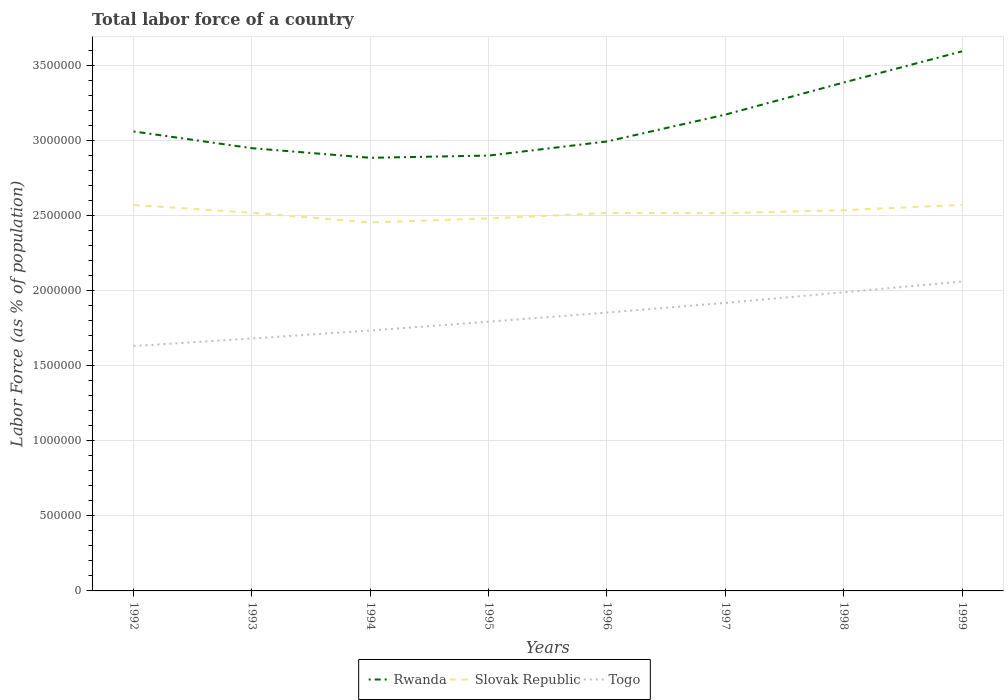How many different coloured lines are there?
Make the answer very short. 3. Does the line corresponding to Slovak Republic intersect with the line corresponding to Togo?
Give a very brief answer. No. Across all years, what is the maximum percentage of labor force in Togo?
Your answer should be very brief. 1.63e+06. What is the total percentage of labor force in Slovak Republic in the graph?
Provide a succinct answer. -5.50e+04. What is the difference between the highest and the second highest percentage of labor force in Togo?
Give a very brief answer. 4.30e+05. What is the difference between the highest and the lowest percentage of labor force in Rwanda?
Keep it short and to the point. 3. Are the values on the major ticks of Y-axis written in scientific E-notation?
Your answer should be compact. No. Does the graph contain grids?
Offer a very short reply. Yes. How many legend labels are there?
Your answer should be very brief. 3. What is the title of the graph?
Your response must be concise. Total labor force of a country. Does "Iraq" appear as one of the legend labels in the graph?
Provide a short and direct response. No. What is the label or title of the X-axis?
Your answer should be very brief. Years. What is the label or title of the Y-axis?
Ensure brevity in your answer.  Labor Force (as % of population). What is the Labor Force (as % of population) of Rwanda in 1992?
Give a very brief answer. 3.06e+06. What is the Labor Force (as % of population) of Slovak Republic in 1992?
Provide a succinct answer. 2.57e+06. What is the Labor Force (as % of population) of Togo in 1992?
Provide a short and direct response. 1.63e+06. What is the Labor Force (as % of population) of Rwanda in 1993?
Make the answer very short. 2.95e+06. What is the Labor Force (as % of population) in Slovak Republic in 1993?
Provide a succinct answer. 2.52e+06. What is the Labor Force (as % of population) in Togo in 1993?
Ensure brevity in your answer.  1.68e+06. What is the Labor Force (as % of population) of Rwanda in 1994?
Your answer should be very brief. 2.89e+06. What is the Labor Force (as % of population) of Slovak Republic in 1994?
Offer a very short reply. 2.45e+06. What is the Labor Force (as % of population) of Togo in 1994?
Provide a short and direct response. 1.73e+06. What is the Labor Force (as % of population) of Rwanda in 1995?
Your answer should be very brief. 2.90e+06. What is the Labor Force (as % of population) of Slovak Republic in 1995?
Your answer should be very brief. 2.48e+06. What is the Labor Force (as % of population) of Togo in 1995?
Provide a succinct answer. 1.79e+06. What is the Labor Force (as % of population) of Rwanda in 1996?
Offer a terse response. 2.99e+06. What is the Labor Force (as % of population) in Slovak Republic in 1996?
Give a very brief answer. 2.52e+06. What is the Labor Force (as % of population) of Togo in 1996?
Give a very brief answer. 1.85e+06. What is the Labor Force (as % of population) of Rwanda in 1997?
Your answer should be very brief. 3.17e+06. What is the Labor Force (as % of population) in Slovak Republic in 1997?
Make the answer very short. 2.52e+06. What is the Labor Force (as % of population) of Togo in 1997?
Ensure brevity in your answer.  1.92e+06. What is the Labor Force (as % of population) in Rwanda in 1998?
Your answer should be very brief. 3.39e+06. What is the Labor Force (as % of population) of Slovak Republic in 1998?
Keep it short and to the point. 2.54e+06. What is the Labor Force (as % of population) in Togo in 1998?
Provide a succinct answer. 1.99e+06. What is the Labor Force (as % of population) in Rwanda in 1999?
Give a very brief answer. 3.59e+06. What is the Labor Force (as % of population) in Slovak Republic in 1999?
Provide a short and direct response. 2.57e+06. What is the Labor Force (as % of population) in Togo in 1999?
Your answer should be very brief. 2.06e+06. Across all years, what is the maximum Labor Force (as % of population) of Rwanda?
Keep it short and to the point. 3.59e+06. Across all years, what is the maximum Labor Force (as % of population) in Slovak Republic?
Give a very brief answer. 2.57e+06. Across all years, what is the maximum Labor Force (as % of population) of Togo?
Your answer should be compact. 2.06e+06. Across all years, what is the minimum Labor Force (as % of population) in Rwanda?
Make the answer very short. 2.89e+06. Across all years, what is the minimum Labor Force (as % of population) in Slovak Republic?
Your answer should be compact. 2.45e+06. Across all years, what is the minimum Labor Force (as % of population) in Togo?
Ensure brevity in your answer.  1.63e+06. What is the total Labor Force (as % of population) in Rwanda in the graph?
Make the answer very short. 2.49e+07. What is the total Labor Force (as % of population) in Slovak Republic in the graph?
Your answer should be compact. 2.02e+07. What is the total Labor Force (as % of population) in Togo in the graph?
Ensure brevity in your answer.  1.47e+07. What is the difference between the Labor Force (as % of population) in Rwanda in 1992 and that in 1993?
Offer a very short reply. 1.12e+05. What is the difference between the Labor Force (as % of population) of Slovak Republic in 1992 and that in 1993?
Make the answer very short. 5.18e+04. What is the difference between the Labor Force (as % of population) of Togo in 1992 and that in 1993?
Ensure brevity in your answer.  -5.02e+04. What is the difference between the Labor Force (as % of population) of Rwanda in 1992 and that in 1994?
Give a very brief answer. 1.76e+05. What is the difference between the Labor Force (as % of population) of Slovak Republic in 1992 and that in 1994?
Your response must be concise. 1.16e+05. What is the difference between the Labor Force (as % of population) of Togo in 1992 and that in 1994?
Keep it short and to the point. -1.03e+05. What is the difference between the Labor Force (as % of population) in Rwanda in 1992 and that in 1995?
Keep it short and to the point. 1.61e+05. What is the difference between the Labor Force (as % of population) of Slovak Republic in 1992 and that in 1995?
Your answer should be very brief. 8.97e+04. What is the difference between the Labor Force (as % of population) in Togo in 1992 and that in 1995?
Your answer should be very brief. -1.62e+05. What is the difference between the Labor Force (as % of population) of Rwanda in 1992 and that in 1996?
Offer a terse response. 6.68e+04. What is the difference between the Labor Force (as % of population) of Slovak Republic in 1992 and that in 1996?
Provide a short and direct response. 5.32e+04. What is the difference between the Labor Force (as % of population) in Togo in 1992 and that in 1996?
Make the answer very short. -2.23e+05. What is the difference between the Labor Force (as % of population) of Rwanda in 1992 and that in 1997?
Give a very brief answer. -1.12e+05. What is the difference between the Labor Force (as % of population) of Slovak Republic in 1992 and that in 1997?
Your answer should be compact. 5.40e+04. What is the difference between the Labor Force (as % of population) in Togo in 1992 and that in 1997?
Ensure brevity in your answer.  -2.87e+05. What is the difference between the Labor Force (as % of population) in Rwanda in 1992 and that in 1998?
Give a very brief answer. -3.26e+05. What is the difference between the Labor Force (as % of population) in Slovak Republic in 1992 and that in 1998?
Your response must be concise. 3.47e+04. What is the difference between the Labor Force (as % of population) of Togo in 1992 and that in 1998?
Your answer should be very brief. -3.58e+05. What is the difference between the Labor Force (as % of population) in Rwanda in 1992 and that in 1999?
Offer a very short reply. -5.34e+05. What is the difference between the Labor Force (as % of population) in Slovak Republic in 1992 and that in 1999?
Make the answer very short. -1093. What is the difference between the Labor Force (as % of population) in Togo in 1992 and that in 1999?
Provide a succinct answer. -4.30e+05. What is the difference between the Labor Force (as % of population) of Rwanda in 1993 and that in 1994?
Offer a terse response. 6.39e+04. What is the difference between the Labor Force (as % of population) of Slovak Republic in 1993 and that in 1994?
Your answer should be compact. 6.44e+04. What is the difference between the Labor Force (as % of population) in Togo in 1993 and that in 1994?
Keep it short and to the point. -5.31e+04. What is the difference between the Labor Force (as % of population) of Rwanda in 1993 and that in 1995?
Keep it short and to the point. 4.92e+04. What is the difference between the Labor Force (as % of population) in Slovak Republic in 1993 and that in 1995?
Your answer should be very brief. 3.79e+04. What is the difference between the Labor Force (as % of population) of Togo in 1993 and that in 1995?
Give a very brief answer. -1.12e+05. What is the difference between the Labor Force (as % of population) of Rwanda in 1993 and that in 1996?
Your answer should be very brief. -4.48e+04. What is the difference between the Labor Force (as % of population) of Slovak Republic in 1993 and that in 1996?
Offer a terse response. 1414. What is the difference between the Labor Force (as % of population) of Togo in 1993 and that in 1996?
Your answer should be compact. -1.73e+05. What is the difference between the Labor Force (as % of population) in Rwanda in 1993 and that in 1997?
Make the answer very short. -2.24e+05. What is the difference between the Labor Force (as % of population) in Slovak Republic in 1993 and that in 1997?
Keep it short and to the point. 2242. What is the difference between the Labor Force (as % of population) in Togo in 1993 and that in 1997?
Give a very brief answer. -2.37e+05. What is the difference between the Labor Force (as % of population) of Rwanda in 1993 and that in 1998?
Provide a short and direct response. -4.38e+05. What is the difference between the Labor Force (as % of population) in Slovak Republic in 1993 and that in 1998?
Offer a very short reply. -1.71e+04. What is the difference between the Labor Force (as % of population) in Togo in 1993 and that in 1998?
Your answer should be compact. -3.08e+05. What is the difference between the Labor Force (as % of population) of Rwanda in 1993 and that in 1999?
Keep it short and to the point. -6.45e+05. What is the difference between the Labor Force (as % of population) of Slovak Republic in 1993 and that in 1999?
Ensure brevity in your answer.  -5.29e+04. What is the difference between the Labor Force (as % of population) in Togo in 1993 and that in 1999?
Offer a very short reply. -3.79e+05. What is the difference between the Labor Force (as % of population) in Rwanda in 1994 and that in 1995?
Ensure brevity in your answer.  -1.48e+04. What is the difference between the Labor Force (as % of population) of Slovak Republic in 1994 and that in 1995?
Keep it short and to the point. -2.65e+04. What is the difference between the Labor Force (as % of population) in Togo in 1994 and that in 1995?
Your answer should be compact. -5.88e+04. What is the difference between the Labor Force (as % of population) of Rwanda in 1994 and that in 1996?
Your answer should be compact. -1.09e+05. What is the difference between the Labor Force (as % of population) in Slovak Republic in 1994 and that in 1996?
Your answer should be compact. -6.30e+04. What is the difference between the Labor Force (as % of population) of Togo in 1994 and that in 1996?
Provide a short and direct response. -1.20e+05. What is the difference between the Labor Force (as % of population) of Rwanda in 1994 and that in 1997?
Offer a terse response. -2.88e+05. What is the difference between the Labor Force (as % of population) of Slovak Republic in 1994 and that in 1997?
Your answer should be compact. -6.22e+04. What is the difference between the Labor Force (as % of population) of Togo in 1994 and that in 1997?
Give a very brief answer. -1.84e+05. What is the difference between the Labor Force (as % of population) of Rwanda in 1994 and that in 1998?
Offer a terse response. -5.01e+05. What is the difference between the Labor Force (as % of population) in Slovak Republic in 1994 and that in 1998?
Offer a terse response. -8.16e+04. What is the difference between the Labor Force (as % of population) in Togo in 1994 and that in 1998?
Your response must be concise. -2.55e+05. What is the difference between the Labor Force (as % of population) in Rwanda in 1994 and that in 1999?
Keep it short and to the point. -7.09e+05. What is the difference between the Labor Force (as % of population) of Slovak Republic in 1994 and that in 1999?
Your answer should be compact. -1.17e+05. What is the difference between the Labor Force (as % of population) of Togo in 1994 and that in 1999?
Give a very brief answer. -3.26e+05. What is the difference between the Labor Force (as % of population) in Rwanda in 1995 and that in 1996?
Provide a short and direct response. -9.40e+04. What is the difference between the Labor Force (as % of population) in Slovak Republic in 1995 and that in 1996?
Provide a short and direct response. -3.65e+04. What is the difference between the Labor Force (as % of population) in Togo in 1995 and that in 1996?
Your answer should be compact. -6.08e+04. What is the difference between the Labor Force (as % of population) in Rwanda in 1995 and that in 1997?
Offer a terse response. -2.73e+05. What is the difference between the Labor Force (as % of population) in Slovak Republic in 1995 and that in 1997?
Your answer should be compact. -3.57e+04. What is the difference between the Labor Force (as % of population) of Togo in 1995 and that in 1997?
Ensure brevity in your answer.  -1.25e+05. What is the difference between the Labor Force (as % of population) in Rwanda in 1995 and that in 1998?
Ensure brevity in your answer.  -4.87e+05. What is the difference between the Labor Force (as % of population) in Slovak Republic in 1995 and that in 1998?
Your answer should be very brief. -5.50e+04. What is the difference between the Labor Force (as % of population) of Togo in 1995 and that in 1998?
Give a very brief answer. -1.96e+05. What is the difference between the Labor Force (as % of population) of Rwanda in 1995 and that in 1999?
Offer a terse response. -6.94e+05. What is the difference between the Labor Force (as % of population) in Slovak Republic in 1995 and that in 1999?
Provide a succinct answer. -9.08e+04. What is the difference between the Labor Force (as % of population) in Togo in 1995 and that in 1999?
Keep it short and to the point. -2.68e+05. What is the difference between the Labor Force (as % of population) of Rwanda in 1996 and that in 1997?
Offer a terse response. -1.79e+05. What is the difference between the Labor Force (as % of population) of Slovak Republic in 1996 and that in 1997?
Your answer should be compact. 828. What is the difference between the Labor Force (as % of population) of Togo in 1996 and that in 1997?
Provide a succinct answer. -6.45e+04. What is the difference between the Labor Force (as % of population) of Rwanda in 1996 and that in 1998?
Keep it short and to the point. -3.93e+05. What is the difference between the Labor Force (as % of population) in Slovak Republic in 1996 and that in 1998?
Offer a terse response. -1.85e+04. What is the difference between the Labor Force (as % of population) of Togo in 1996 and that in 1998?
Provide a succinct answer. -1.35e+05. What is the difference between the Labor Force (as % of population) of Rwanda in 1996 and that in 1999?
Provide a succinct answer. -6.00e+05. What is the difference between the Labor Force (as % of population) in Slovak Republic in 1996 and that in 1999?
Give a very brief answer. -5.43e+04. What is the difference between the Labor Force (as % of population) of Togo in 1996 and that in 1999?
Provide a short and direct response. -2.07e+05. What is the difference between the Labor Force (as % of population) of Rwanda in 1997 and that in 1998?
Keep it short and to the point. -2.14e+05. What is the difference between the Labor Force (as % of population) in Slovak Republic in 1997 and that in 1998?
Make the answer very short. -1.93e+04. What is the difference between the Labor Force (as % of population) in Togo in 1997 and that in 1998?
Make the answer very short. -7.06e+04. What is the difference between the Labor Force (as % of population) of Rwanda in 1997 and that in 1999?
Provide a short and direct response. -4.22e+05. What is the difference between the Labor Force (as % of population) in Slovak Republic in 1997 and that in 1999?
Offer a very short reply. -5.51e+04. What is the difference between the Labor Force (as % of population) of Togo in 1997 and that in 1999?
Provide a succinct answer. -1.42e+05. What is the difference between the Labor Force (as % of population) of Rwanda in 1998 and that in 1999?
Keep it short and to the point. -2.08e+05. What is the difference between the Labor Force (as % of population) of Slovak Republic in 1998 and that in 1999?
Your answer should be very brief. -3.58e+04. What is the difference between the Labor Force (as % of population) of Togo in 1998 and that in 1999?
Offer a very short reply. -7.16e+04. What is the difference between the Labor Force (as % of population) in Rwanda in 1992 and the Labor Force (as % of population) in Slovak Republic in 1993?
Provide a short and direct response. 5.42e+05. What is the difference between the Labor Force (as % of population) in Rwanda in 1992 and the Labor Force (as % of population) in Togo in 1993?
Ensure brevity in your answer.  1.38e+06. What is the difference between the Labor Force (as % of population) of Slovak Republic in 1992 and the Labor Force (as % of population) of Togo in 1993?
Your response must be concise. 8.89e+05. What is the difference between the Labor Force (as % of population) of Rwanda in 1992 and the Labor Force (as % of population) of Slovak Republic in 1994?
Your answer should be compact. 6.06e+05. What is the difference between the Labor Force (as % of population) of Rwanda in 1992 and the Labor Force (as % of population) of Togo in 1994?
Keep it short and to the point. 1.33e+06. What is the difference between the Labor Force (as % of population) in Slovak Republic in 1992 and the Labor Force (as % of population) in Togo in 1994?
Your answer should be very brief. 8.36e+05. What is the difference between the Labor Force (as % of population) in Rwanda in 1992 and the Labor Force (as % of population) in Slovak Republic in 1995?
Ensure brevity in your answer.  5.80e+05. What is the difference between the Labor Force (as % of population) of Rwanda in 1992 and the Labor Force (as % of population) of Togo in 1995?
Offer a terse response. 1.27e+06. What is the difference between the Labor Force (as % of population) of Slovak Republic in 1992 and the Labor Force (as % of population) of Togo in 1995?
Your answer should be very brief. 7.77e+05. What is the difference between the Labor Force (as % of population) in Rwanda in 1992 and the Labor Force (as % of population) in Slovak Republic in 1996?
Offer a very short reply. 5.43e+05. What is the difference between the Labor Force (as % of population) of Rwanda in 1992 and the Labor Force (as % of population) of Togo in 1996?
Give a very brief answer. 1.21e+06. What is the difference between the Labor Force (as % of population) in Slovak Republic in 1992 and the Labor Force (as % of population) in Togo in 1996?
Offer a very short reply. 7.17e+05. What is the difference between the Labor Force (as % of population) of Rwanda in 1992 and the Labor Force (as % of population) of Slovak Republic in 1997?
Your answer should be very brief. 5.44e+05. What is the difference between the Labor Force (as % of population) of Rwanda in 1992 and the Labor Force (as % of population) of Togo in 1997?
Ensure brevity in your answer.  1.14e+06. What is the difference between the Labor Force (as % of population) of Slovak Republic in 1992 and the Labor Force (as % of population) of Togo in 1997?
Provide a short and direct response. 6.52e+05. What is the difference between the Labor Force (as % of population) in Rwanda in 1992 and the Labor Force (as % of population) in Slovak Republic in 1998?
Your answer should be compact. 5.25e+05. What is the difference between the Labor Force (as % of population) of Rwanda in 1992 and the Labor Force (as % of population) of Togo in 1998?
Provide a succinct answer. 1.07e+06. What is the difference between the Labor Force (as % of population) in Slovak Republic in 1992 and the Labor Force (as % of population) in Togo in 1998?
Make the answer very short. 5.82e+05. What is the difference between the Labor Force (as % of population) of Rwanda in 1992 and the Labor Force (as % of population) of Slovak Republic in 1999?
Give a very brief answer. 4.89e+05. What is the difference between the Labor Force (as % of population) in Rwanda in 1992 and the Labor Force (as % of population) in Togo in 1999?
Provide a succinct answer. 1.00e+06. What is the difference between the Labor Force (as % of population) in Slovak Republic in 1992 and the Labor Force (as % of population) in Togo in 1999?
Provide a short and direct response. 5.10e+05. What is the difference between the Labor Force (as % of population) of Rwanda in 1993 and the Labor Force (as % of population) of Slovak Republic in 1994?
Offer a terse response. 4.95e+05. What is the difference between the Labor Force (as % of population) in Rwanda in 1993 and the Labor Force (as % of population) in Togo in 1994?
Make the answer very short. 1.21e+06. What is the difference between the Labor Force (as % of population) in Slovak Republic in 1993 and the Labor Force (as % of population) in Togo in 1994?
Your answer should be compact. 7.84e+05. What is the difference between the Labor Force (as % of population) in Rwanda in 1993 and the Labor Force (as % of population) in Slovak Republic in 1995?
Offer a terse response. 4.68e+05. What is the difference between the Labor Force (as % of population) in Rwanda in 1993 and the Labor Force (as % of population) in Togo in 1995?
Provide a succinct answer. 1.16e+06. What is the difference between the Labor Force (as % of population) of Slovak Republic in 1993 and the Labor Force (as % of population) of Togo in 1995?
Your answer should be very brief. 7.26e+05. What is the difference between the Labor Force (as % of population) of Rwanda in 1993 and the Labor Force (as % of population) of Slovak Republic in 1996?
Provide a succinct answer. 4.32e+05. What is the difference between the Labor Force (as % of population) in Rwanda in 1993 and the Labor Force (as % of population) in Togo in 1996?
Make the answer very short. 1.09e+06. What is the difference between the Labor Force (as % of population) in Slovak Republic in 1993 and the Labor Force (as % of population) in Togo in 1996?
Keep it short and to the point. 6.65e+05. What is the difference between the Labor Force (as % of population) of Rwanda in 1993 and the Labor Force (as % of population) of Slovak Republic in 1997?
Ensure brevity in your answer.  4.32e+05. What is the difference between the Labor Force (as % of population) of Rwanda in 1993 and the Labor Force (as % of population) of Togo in 1997?
Provide a short and direct response. 1.03e+06. What is the difference between the Labor Force (as % of population) in Slovak Republic in 1993 and the Labor Force (as % of population) in Togo in 1997?
Keep it short and to the point. 6.00e+05. What is the difference between the Labor Force (as % of population) of Rwanda in 1993 and the Labor Force (as % of population) of Slovak Republic in 1998?
Your answer should be very brief. 4.13e+05. What is the difference between the Labor Force (as % of population) of Rwanda in 1993 and the Labor Force (as % of population) of Togo in 1998?
Give a very brief answer. 9.60e+05. What is the difference between the Labor Force (as % of population) of Slovak Republic in 1993 and the Labor Force (as % of population) of Togo in 1998?
Offer a terse response. 5.30e+05. What is the difference between the Labor Force (as % of population) of Rwanda in 1993 and the Labor Force (as % of population) of Slovak Republic in 1999?
Provide a short and direct response. 3.77e+05. What is the difference between the Labor Force (as % of population) in Rwanda in 1993 and the Labor Force (as % of population) in Togo in 1999?
Give a very brief answer. 8.88e+05. What is the difference between the Labor Force (as % of population) of Slovak Republic in 1993 and the Labor Force (as % of population) of Togo in 1999?
Your answer should be very brief. 4.58e+05. What is the difference between the Labor Force (as % of population) of Rwanda in 1994 and the Labor Force (as % of population) of Slovak Republic in 1995?
Make the answer very short. 4.04e+05. What is the difference between the Labor Force (as % of population) of Rwanda in 1994 and the Labor Force (as % of population) of Togo in 1995?
Give a very brief answer. 1.09e+06. What is the difference between the Labor Force (as % of population) of Slovak Republic in 1994 and the Labor Force (as % of population) of Togo in 1995?
Ensure brevity in your answer.  6.61e+05. What is the difference between the Labor Force (as % of population) of Rwanda in 1994 and the Labor Force (as % of population) of Slovak Republic in 1996?
Your response must be concise. 3.68e+05. What is the difference between the Labor Force (as % of population) in Rwanda in 1994 and the Labor Force (as % of population) in Togo in 1996?
Your response must be concise. 1.03e+06. What is the difference between the Labor Force (as % of population) of Slovak Republic in 1994 and the Labor Force (as % of population) of Togo in 1996?
Provide a short and direct response. 6.00e+05. What is the difference between the Labor Force (as % of population) of Rwanda in 1994 and the Labor Force (as % of population) of Slovak Republic in 1997?
Your answer should be compact. 3.68e+05. What is the difference between the Labor Force (as % of population) of Rwanda in 1994 and the Labor Force (as % of population) of Togo in 1997?
Offer a terse response. 9.67e+05. What is the difference between the Labor Force (as % of population) in Slovak Republic in 1994 and the Labor Force (as % of population) in Togo in 1997?
Provide a succinct answer. 5.36e+05. What is the difference between the Labor Force (as % of population) in Rwanda in 1994 and the Labor Force (as % of population) in Slovak Republic in 1998?
Ensure brevity in your answer.  3.49e+05. What is the difference between the Labor Force (as % of population) of Rwanda in 1994 and the Labor Force (as % of population) of Togo in 1998?
Keep it short and to the point. 8.96e+05. What is the difference between the Labor Force (as % of population) of Slovak Republic in 1994 and the Labor Force (as % of population) of Togo in 1998?
Give a very brief answer. 4.65e+05. What is the difference between the Labor Force (as % of population) in Rwanda in 1994 and the Labor Force (as % of population) in Slovak Republic in 1999?
Your answer should be very brief. 3.13e+05. What is the difference between the Labor Force (as % of population) in Rwanda in 1994 and the Labor Force (as % of population) in Togo in 1999?
Offer a very short reply. 8.24e+05. What is the difference between the Labor Force (as % of population) in Slovak Republic in 1994 and the Labor Force (as % of population) in Togo in 1999?
Offer a terse response. 3.94e+05. What is the difference between the Labor Force (as % of population) in Rwanda in 1995 and the Labor Force (as % of population) in Slovak Republic in 1996?
Ensure brevity in your answer.  3.82e+05. What is the difference between the Labor Force (as % of population) of Rwanda in 1995 and the Labor Force (as % of population) of Togo in 1996?
Provide a short and direct response. 1.05e+06. What is the difference between the Labor Force (as % of population) of Slovak Republic in 1995 and the Labor Force (as % of population) of Togo in 1996?
Give a very brief answer. 6.27e+05. What is the difference between the Labor Force (as % of population) of Rwanda in 1995 and the Labor Force (as % of population) of Slovak Republic in 1997?
Offer a very short reply. 3.83e+05. What is the difference between the Labor Force (as % of population) of Rwanda in 1995 and the Labor Force (as % of population) of Togo in 1997?
Provide a short and direct response. 9.81e+05. What is the difference between the Labor Force (as % of population) in Slovak Republic in 1995 and the Labor Force (as % of population) in Togo in 1997?
Provide a short and direct response. 5.62e+05. What is the difference between the Labor Force (as % of population) in Rwanda in 1995 and the Labor Force (as % of population) in Slovak Republic in 1998?
Keep it short and to the point. 3.64e+05. What is the difference between the Labor Force (as % of population) in Rwanda in 1995 and the Labor Force (as % of population) in Togo in 1998?
Ensure brevity in your answer.  9.11e+05. What is the difference between the Labor Force (as % of population) in Slovak Republic in 1995 and the Labor Force (as % of population) in Togo in 1998?
Ensure brevity in your answer.  4.92e+05. What is the difference between the Labor Force (as % of population) of Rwanda in 1995 and the Labor Force (as % of population) of Slovak Republic in 1999?
Offer a very short reply. 3.28e+05. What is the difference between the Labor Force (as % of population) in Rwanda in 1995 and the Labor Force (as % of population) in Togo in 1999?
Your response must be concise. 8.39e+05. What is the difference between the Labor Force (as % of population) in Slovak Republic in 1995 and the Labor Force (as % of population) in Togo in 1999?
Offer a terse response. 4.20e+05. What is the difference between the Labor Force (as % of population) in Rwanda in 1996 and the Labor Force (as % of population) in Slovak Republic in 1997?
Ensure brevity in your answer.  4.77e+05. What is the difference between the Labor Force (as % of population) in Rwanda in 1996 and the Labor Force (as % of population) in Togo in 1997?
Your response must be concise. 1.08e+06. What is the difference between the Labor Force (as % of population) of Slovak Republic in 1996 and the Labor Force (as % of population) of Togo in 1997?
Your answer should be very brief. 5.99e+05. What is the difference between the Labor Force (as % of population) in Rwanda in 1996 and the Labor Force (as % of population) in Slovak Republic in 1998?
Provide a short and direct response. 4.58e+05. What is the difference between the Labor Force (as % of population) in Rwanda in 1996 and the Labor Force (as % of population) in Togo in 1998?
Ensure brevity in your answer.  1.00e+06. What is the difference between the Labor Force (as % of population) in Slovak Republic in 1996 and the Labor Force (as % of population) in Togo in 1998?
Give a very brief answer. 5.28e+05. What is the difference between the Labor Force (as % of population) of Rwanda in 1996 and the Labor Force (as % of population) of Slovak Republic in 1999?
Provide a succinct answer. 4.22e+05. What is the difference between the Labor Force (as % of population) in Rwanda in 1996 and the Labor Force (as % of population) in Togo in 1999?
Make the answer very short. 9.33e+05. What is the difference between the Labor Force (as % of population) in Slovak Republic in 1996 and the Labor Force (as % of population) in Togo in 1999?
Offer a terse response. 4.57e+05. What is the difference between the Labor Force (as % of population) of Rwanda in 1997 and the Labor Force (as % of population) of Slovak Republic in 1998?
Offer a terse response. 6.37e+05. What is the difference between the Labor Force (as % of population) of Rwanda in 1997 and the Labor Force (as % of population) of Togo in 1998?
Give a very brief answer. 1.18e+06. What is the difference between the Labor Force (as % of population) of Slovak Republic in 1997 and the Labor Force (as % of population) of Togo in 1998?
Provide a short and direct response. 5.27e+05. What is the difference between the Labor Force (as % of population) in Rwanda in 1997 and the Labor Force (as % of population) in Slovak Republic in 1999?
Provide a short and direct response. 6.01e+05. What is the difference between the Labor Force (as % of population) in Rwanda in 1997 and the Labor Force (as % of population) in Togo in 1999?
Provide a short and direct response. 1.11e+06. What is the difference between the Labor Force (as % of population) in Slovak Republic in 1997 and the Labor Force (as % of population) in Togo in 1999?
Ensure brevity in your answer.  4.56e+05. What is the difference between the Labor Force (as % of population) in Rwanda in 1998 and the Labor Force (as % of population) in Slovak Republic in 1999?
Provide a short and direct response. 8.15e+05. What is the difference between the Labor Force (as % of population) of Rwanda in 1998 and the Labor Force (as % of population) of Togo in 1999?
Give a very brief answer. 1.33e+06. What is the difference between the Labor Force (as % of population) of Slovak Republic in 1998 and the Labor Force (as % of population) of Togo in 1999?
Offer a terse response. 4.75e+05. What is the average Labor Force (as % of population) of Rwanda per year?
Offer a very short reply. 3.12e+06. What is the average Labor Force (as % of population) in Slovak Republic per year?
Your answer should be very brief. 2.52e+06. What is the average Labor Force (as % of population) in Togo per year?
Your response must be concise. 1.83e+06. In the year 1992, what is the difference between the Labor Force (as % of population) in Rwanda and Labor Force (as % of population) in Slovak Republic?
Keep it short and to the point. 4.90e+05. In the year 1992, what is the difference between the Labor Force (as % of population) of Rwanda and Labor Force (as % of population) of Togo?
Your answer should be very brief. 1.43e+06. In the year 1992, what is the difference between the Labor Force (as % of population) of Slovak Republic and Labor Force (as % of population) of Togo?
Ensure brevity in your answer.  9.39e+05. In the year 1993, what is the difference between the Labor Force (as % of population) in Rwanda and Labor Force (as % of population) in Slovak Republic?
Your answer should be compact. 4.30e+05. In the year 1993, what is the difference between the Labor Force (as % of population) in Rwanda and Labor Force (as % of population) in Togo?
Your answer should be compact. 1.27e+06. In the year 1993, what is the difference between the Labor Force (as % of population) of Slovak Republic and Labor Force (as % of population) of Togo?
Offer a terse response. 8.38e+05. In the year 1994, what is the difference between the Labor Force (as % of population) in Rwanda and Labor Force (as % of population) in Slovak Republic?
Give a very brief answer. 4.31e+05. In the year 1994, what is the difference between the Labor Force (as % of population) of Rwanda and Labor Force (as % of population) of Togo?
Provide a succinct answer. 1.15e+06. In the year 1994, what is the difference between the Labor Force (as % of population) of Slovak Republic and Labor Force (as % of population) of Togo?
Offer a very short reply. 7.20e+05. In the year 1995, what is the difference between the Labor Force (as % of population) in Rwanda and Labor Force (as % of population) in Slovak Republic?
Make the answer very short. 4.19e+05. In the year 1995, what is the difference between the Labor Force (as % of population) of Rwanda and Labor Force (as % of population) of Togo?
Give a very brief answer. 1.11e+06. In the year 1995, what is the difference between the Labor Force (as % of population) of Slovak Republic and Labor Force (as % of population) of Togo?
Your response must be concise. 6.88e+05. In the year 1996, what is the difference between the Labor Force (as % of population) in Rwanda and Labor Force (as % of population) in Slovak Republic?
Provide a short and direct response. 4.76e+05. In the year 1996, what is the difference between the Labor Force (as % of population) of Rwanda and Labor Force (as % of population) of Togo?
Provide a succinct answer. 1.14e+06. In the year 1996, what is the difference between the Labor Force (as % of population) in Slovak Republic and Labor Force (as % of population) in Togo?
Keep it short and to the point. 6.63e+05. In the year 1997, what is the difference between the Labor Force (as % of population) of Rwanda and Labor Force (as % of population) of Slovak Republic?
Give a very brief answer. 6.56e+05. In the year 1997, what is the difference between the Labor Force (as % of population) of Rwanda and Labor Force (as % of population) of Togo?
Ensure brevity in your answer.  1.25e+06. In the year 1997, what is the difference between the Labor Force (as % of population) in Slovak Republic and Labor Force (as % of population) in Togo?
Provide a succinct answer. 5.98e+05. In the year 1998, what is the difference between the Labor Force (as % of population) of Rwanda and Labor Force (as % of population) of Slovak Republic?
Provide a short and direct response. 8.51e+05. In the year 1998, what is the difference between the Labor Force (as % of population) of Rwanda and Labor Force (as % of population) of Togo?
Your response must be concise. 1.40e+06. In the year 1998, what is the difference between the Labor Force (as % of population) of Slovak Republic and Labor Force (as % of population) of Togo?
Offer a terse response. 5.47e+05. In the year 1999, what is the difference between the Labor Force (as % of population) in Rwanda and Labor Force (as % of population) in Slovak Republic?
Ensure brevity in your answer.  1.02e+06. In the year 1999, what is the difference between the Labor Force (as % of population) of Rwanda and Labor Force (as % of population) of Togo?
Keep it short and to the point. 1.53e+06. In the year 1999, what is the difference between the Labor Force (as % of population) in Slovak Republic and Labor Force (as % of population) in Togo?
Provide a short and direct response. 5.11e+05. What is the ratio of the Labor Force (as % of population) in Rwanda in 1992 to that in 1993?
Make the answer very short. 1.04. What is the ratio of the Labor Force (as % of population) in Slovak Republic in 1992 to that in 1993?
Provide a succinct answer. 1.02. What is the ratio of the Labor Force (as % of population) in Togo in 1992 to that in 1993?
Your answer should be compact. 0.97. What is the ratio of the Labor Force (as % of population) in Rwanda in 1992 to that in 1994?
Make the answer very short. 1.06. What is the ratio of the Labor Force (as % of population) in Slovak Republic in 1992 to that in 1994?
Your response must be concise. 1.05. What is the ratio of the Labor Force (as % of population) in Togo in 1992 to that in 1994?
Your response must be concise. 0.94. What is the ratio of the Labor Force (as % of population) in Rwanda in 1992 to that in 1995?
Your answer should be compact. 1.06. What is the ratio of the Labor Force (as % of population) of Slovak Republic in 1992 to that in 1995?
Provide a short and direct response. 1.04. What is the ratio of the Labor Force (as % of population) of Togo in 1992 to that in 1995?
Your response must be concise. 0.91. What is the ratio of the Labor Force (as % of population) in Rwanda in 1992 to that in 1996?
Make the answer very short. 1.02. What is the ratio of the Labor Force (as % of population) of Slovak Republic in 1992 to that in 1996?
Offer a very short reply. 1.02. What is the ratio of the Labor Force (as % of population) of Togo in 1992 to that in 1996?
Give a very brief answer. 0.88. What is the ratio of the Labor Force (as % of population) of Rwanda in 1992 to that in 1997?
Your answer should be very brief. 0.96. What is the ratio of the Labor Force (as % of population) of Slovak Republic in 1992 to that in 1997?
Your answer should be very brief. 1.02. What is the ratio of the Labor Force (as % of population) of Togo in 1992 to that in 1997?
Provide a short and direct response. 0.85. What is the ratio of the Labor Force (as % of population) in Rwanda in 1992 to that in 1998?
Provide a short and direct response. 0.9. What is the ratio of the Labor Force (as % of population) of Slovak Republic in 1992 to that in 1998?
Provide a short and direct response. 1.01. What is the ratio of the Labor Force (as % of population) of Togo in 1992 to that in 1998?
Offer a very short reply. 0.82. What is the ratio of the Labor Force (as % of population) of Rwanda in 1992 to that in 1999?
Ensure brevity in your answer.  0.85. What is the ratio of the Labor Force (as % of population) in Slovak Republic in 1992 to that in 1999?
Make the answer very short. 1. What is the ratio of the Labor Force (as % of population) in Togo in 1992 to that in 1999?
Your answer should be very brief. 0.79. What is the ratio of the Labor Force (as % of population) of Rwanda in 1993 to that in 1994?
Your answer should be very brief. 1.02. What is the ratio of the Labor Force (as % of population) in Slovak Republic in 1993 to that in 1994?
Make the answer very short. 1.03. What is the ratio of the Labor Force (as % of population) in Togo in 1993 to that in 1994?
Give a very brief answer. 0.97. What is the ratio of the Labor Force (as % of population) in Rwanda in 1993 to that in 1995?
Keep it short and to the point. 1.02. What is the ratio of the Labor Force (as % of population) of Slovak Republic in 1993 to that in 1995?
Provide a succinct answer. 1.02. What is the ratio of the Labor Force (as % of population) in Togo in 1993 to that in 1995?
Provide a succinct answer. 0.94. What is the ratio of the Labor Force (as % of population) of Rwanda in 1993 to that in 1996?
Offer a very short reply. 0.98. What is the ratio of the Labor Force (as % of population) in Slovak Republic in 1993 to that in 1996?
Make the answer very short. 1. What is the ratio of the Labor Force (as % of population) in Togo in 1993 to that in 1996?
Offer a terse response. 0.91. What is the ratio of the Labor Force (as % of population) in Rwanda in 1993 to that in 1997?
Give a very brief answer. 0.93. What is the ratio of the Labor Force (as % of population) in Togo in 1993 to that in 1997?
Your answer should be very brief. 0.88. What is the ratio of the Labor Force (as % of population) in Rwanda in 1993 to that in 1998?
Give a very brief answer. 0.87. What is the ratio of the Labor Force (as % of population) of Togo in 1993 to that in 1998?
Make the answer very short. 0.85. What is the ratio of the Labor Force (as % of population) in Rwanda in 1993 to that in 1999?
Your answer should be compact. 0.82. What is the ratio of the Labor Force (as % of population) in Slovak Republic in 1993 to that in 1999?
Give a very brief answer. 0.98. What is the ratio of the Labor Force (as % of population) of Togo in 1993 to that in 1999?
Your answer should be very brief. 0.82. What is the ratio of the Labor Force (as % of population) in Rwanda in 1994 to that in 1995?
Offer a terse response. 0.99. What is the ratio of the Labor Force (as % of population) of Slovak Republic in 1994 to that in 1995?
Ensure brevity in your answer.  0.99. What is the ratio of the Labor Force (as % of population) in Togo in 1994 to that in 1995?
Your response must be concise. 0.97. What is the ratio of the Labor Force (as % of population) in Rwanda in 1994 to that in 1996?
Keep it short and to the point. 0.96. What is the ratio of the Labor Force (as % of population) of Slovak Republic in 1994 to that in 1996?
Give a very brief answer. 0.97. What is the ratio of the Labor Force (as % of population) in Togo in 1994 to that in 1996?
Your response must be concise. 0.94. What is the ratio of the Labor Force (as % of population) of Rwanda in 1994 to that in 1997?
Your answer should be very brief. 0.91. What is the ratio of the Labor Force (as % of population) in Slovak Republic in 1994 to that in 1997?
Offer a very short reply. 0.98. What is the ratio of the Labor Force (as % of population) of Togo in 1994 to that in 1997?
Your answer should be very brief. 0.9. What is the ratio of the Labor Force (as % of population) in Rwanda in 1994 to that in 1998?
Ensure brevity in your answer.  0.85. What is the ratio of the Labor Force (as % of population) in Slovak Republic in 1994 to that in 1998?
Give a very brief answer. 0.97. What is the ratio of the Labor Force (as % of population) of Togo in 1994 to that in 1998?
Your answer should be very brief. 0.87. What is the ratio of the Labor Force (as % of population) of Rwanda in 1994 to that in 1999?
Your response must be concise. 0.8. What is the ratio of the Labor Force (as % of population) in Slovak Republic in 1994 to that in 1999?
Provide a succinct answer. 0.95. What is the ratio of the Labor Force (as % of population) of Togo in 1994 to that in 1999?
Keep it short and to the point. 0.84. What is the ratio of the Labor Force (as % of population) of Rwanda in 1995 to that in 1996?
Offer a terse response. 0.97. What is the ratio of the Labor Force (as % of population) of Slovak Republic in 1995 to that in 1996?
Provide a short and direct response. 0.99. What is the ratio of the Labor Force (as % of population) in Togo in 1995 to that in 1996?
Provide a succinct answer. 0.97. What is the ratio of the Labor Force (as % of population) of Rwanda in 1995 to that in 1997?
Your answer should be very brief. 0.91. What is the ratio of the Labor Force (as % of population) of Slovak Republic in 1995 to that in 1997?
Make the answer very short. 0.99. What is the ratio of the Labor Force (as % of population) of Togo in 1995 to that in 1997?
Ensure brevity in your answer.  0.93. What is the ratio of the Labor Force (as % of population) in Rwanda in 1995 to that in 1998?
Your response must be concise. 0.86. What is the ratio of the Labor Force (as % of population) of Slovak Republic in 1995 to that in 1998?
Your answer should be very brief. 0.98. What is the ratio of the Labor Force (as % of population) of Togo in 1995 to that in 1998?
Your answer should be very brief. 0.9. What is the ratio of the Labor Force (as % of population) of Rwanda in 1995 to that in 1999?
Make the answer very short. 0.81. What is the ratio of the Labor Force (as % of population) in Slovak Republic in 1995 to that in 1999?
Offer a very short reply. 0.96. What is the ratio of the Labor Force (as % of population) of Togo in 1995 to that in 1999?
Provide a succinct answer. 0.87. What is the ratio of the Labor Force (as % of population) in Rwanda in 1996 to that in 1997?
Provide a succinct answer. 0.94. What is the ratio of the Labor Force (as % of population) of Slovak Republic in 1996 to that in 1997?
Make the answer very short. 1. What is the ratio of the Labor Force (as % of population) of Togo in 1996 to that in 1997?
Provide a short and direct response. 0.97. What is the ratio of the Labor Force (as % of population) in Rwanda in 1996 to that in 1998?
Your answer should be compact. 0.88. What is the ratio of the Labor Force (as % of population) of Slovak Republic in 1996 to that in 1998?
Give a very brief answer. 0.99. What is the ratio of the Labor Force (as % of population) in Togo in 1996 to that in 1998?
Give a very brief answer. 0.93. What is the ratio of the Labor Force (as % of population) in Rwanda in 1996 to that in 1999?
Provide a short and direct response. 0.83. What is the ratio of the Labor Force (as % of population) in Slovak Republic in 1996 to that in 1999?
Provide a succinct answer. 0.98. What is the ratio of the Labor Force (as % of population) of Togo in 1996 to that in 1999?
Your answer should be very brief. 0.9. What is the ratio of the Labor Force (as % of population) of Rwanda in 1997 to that in 1998?
Make the answer very short. 0.94. What is the ratio of the Labor Force (as % of population) of Togo in 1997 to that in 1998?
Provide a succinct answer. 0.96. What is the ratio of the Labor Force (as % of population) in Rwanda in 1997 to that in 1999?
Keep it short and to the point. 0.88. What is the ratio of the Labor Force (as % of population) in Slovak Republic in 1997 to that in 1999?
Offer a terse response. 0.98. What is the ratio of the Labor Force (as % of population) in Togo in 1997 to that in 1999?
Provide a short and direct response. 0.93. What is the ratio of the Labor Force (as % of population) in Rwanda in 1998 to that in 1999?
Your answer should be very brief. 0.94. What is the ratio of the Labor Force (as % of population) in Slovak Republic in 1998 to that in 1999?
Make the answer very short. 0.99. What is the ratio of the Labor Force (as % of population) in Togo in 1998 to that in 1999?
Your answer should be compact. 0.97. What is the difference between the highest and the second highest Labor Force (as % of population) of Rwanda?
Your response must be concise. 2.08e+05. What is the difference between the highest and the second highest Labor Force (as % of population) in Slovak Republic?
Give a very brief answer. 1093. What is the difference between the highest and the second highest Labor Force (as % of population) of Togo?
Your response must be concise. 7.16e+04. What is the difference between the highest and the lowest Labor Force (as % of population) of Rwanda?
Keep it short and to the point. 7.09e+05. What is the difference between the highest and the lowest Labor Force (as % of population) of Slovak Republic?
Your answer should be very brief. 1.17e+05. What is the difference between the highest and the lowest Labor Force (as % of population) of Togo?
Make the answer very short. 4.30e+05. 